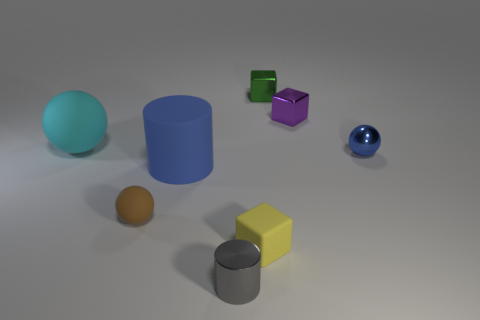There is a big cylinder that is the same color as the small metallic ball; what is it made of?
Your answer should be compact. Rubber. There is a small ball right of the brown thing; what material is it?
Ensure brevity in your answer.  Metal. How many matte things are to the left of the rubber block and in front of the blue matte thing?
Your answer should be compact. 1. There is a purple cube that is the same size as the gray cylinder; what is its material?
Provide a short and direct response. Metal. Do the metal object on the left side of the matte block and the matte ball right of the cyan object have the same size?
Ensure brevity in your answer.  Yes. Are there any blue metal things in front of the metallic cylinder?
Your response must be concise. No. There is a tiny ball behind the tiny rubber object that is left of the small yellow rubber thing; what color is it?
Provide a short and direct response. Blue. Are there fewer large blue things than tiny green shiny spheres?
Offer a very short reply. No. How many small blue objects are the same shape as the big cyan rubber object?
Keep it short and to the point. 1. There is a cylinder that is the same size as the cyan thing; what is its color?
Ensure brevity in your answer.  Blue. 